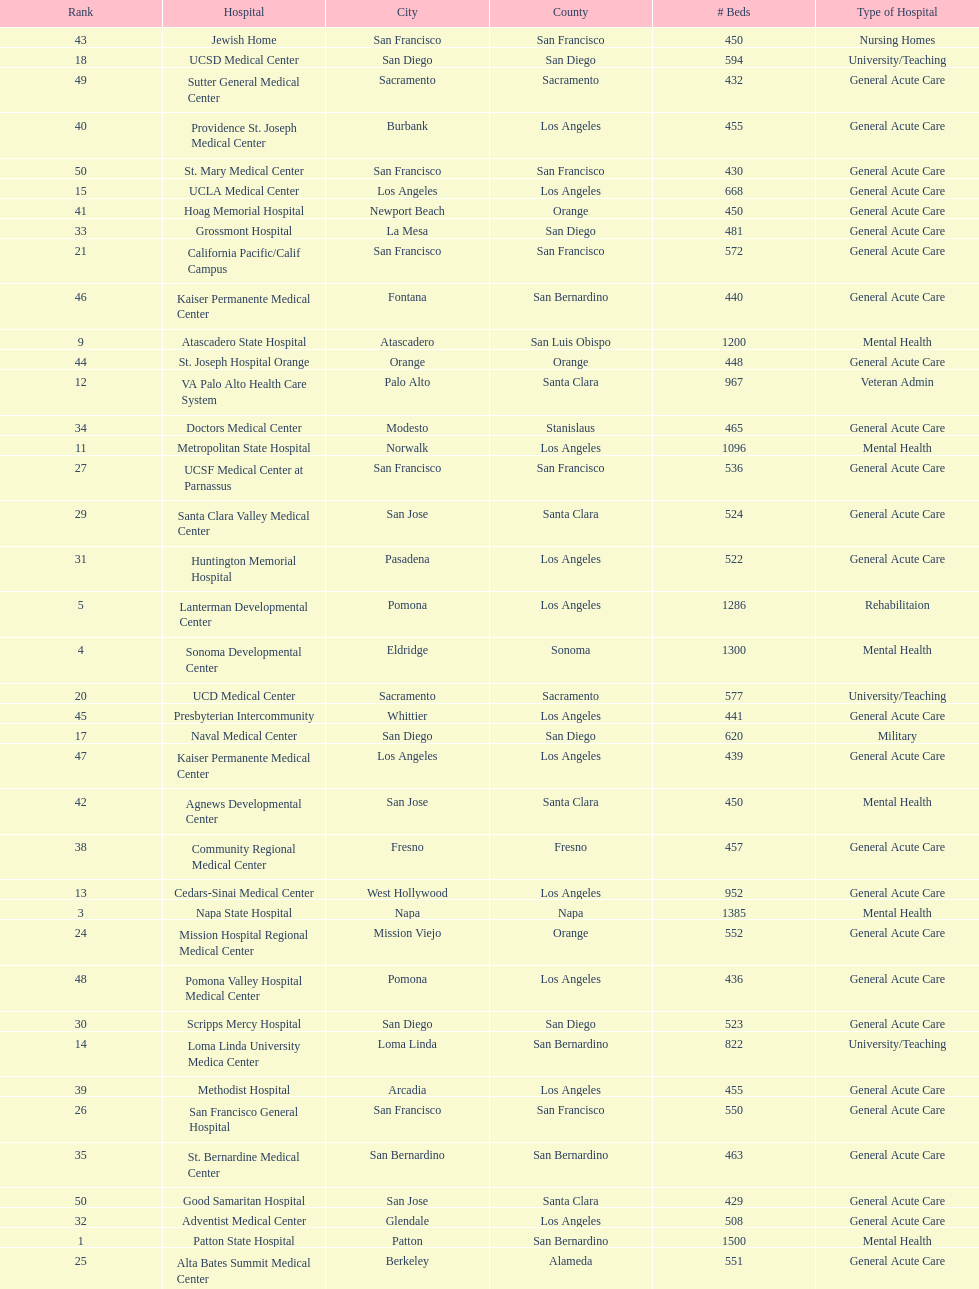Could you parse the entire table as a dict? {'header': ['Rank', 'Hospital', 'City', 'County', '# Beds', 'Type of Hospital'], 'rows': [['43', 'Jewish Home', 'San Francisco', 'San Francisco', '450', 'Nursing Homes'], ['18', 'UCSD Medical Center', 'San Diego', 'San Diego', '594', 'University/Teaching'], ['49', 'Sutter General Medical Center', 'Sacramento', 'Sacramento', '432', 'General Acute Care'], ['40', 'Providence St. Joseph Medical Center', 'Burbank', 'Los Angeles', '455', 'General Acute Care'], ['50', 'St. Mary Medical Center', 'San Francisco', 'San Francisco', '430', 'General Acute Care'], ['15', 'UCLA Medical Center', 'Los Angeles', 'Los Angeles', '668', 'General Acute Care'], ['41', 'Hoag Memorial Hospital', 'Newport Beach', 'Orange', '450', 'General Acute Care'], ['33', 'Grossmont Hospital', 'La Mesa', 'San Diego', '481', 'General Acute Care'], ['21', 'California Pacific/Calif Campus', 'San Francisco', 'San Francisco', '572', 'General Acute Care'], ['46', 'Kaiser Permanente Medical Center', 'Fontana', 'San Bernardino', '440', 'General Acute Care'], ['9', 'Atascadero State Hospital', 'Atascadero', 'San Luis Obispo', '1200', 'Mental Health'], ['44', 'St. Joseph Hospital Orange', 'Orange', 'Orange', '448', 'General Acute Care'], ['12', 'VA Palo Alto Health Care System', 'Palo Alto', 'Santa Clara', '967', 'Veteran Admin'], ['34', 'Doctors Medical Center', 'Modesto', 'Stanislaus', '465', 'General Acute Care'], ['11', 'Metropolitan State Hospital', 'Norwalk', 'Los Angeles', '1096', 'Mental Health'], ['27', 'UCSF Medical Center at Parnassus', 'San Francisco', 'San Francisco', '536', 'General Acute Care'], ['29', 'Santa Clara Valley Medical Center', 'San Jose', 'Santa Clara', '524', 'General Acute Care'], ['31', 'Huntington Memorial Hospital', 'Pasadena', 'Los Angeles', '522', 'General Acute Care'], ['5', 'Lanterman Developmental Center', 'Pomona', 'Los Angeles', '1286', 'Rehabilitaion'], ['4', 'Sonoma Developmental Center', 'Eldridge', 'Sonoma', '1300', 'Mental Health'], ['20', 'UCD Medical Center', 'Sacramento', 'Sacramento', '577', 'University/Teaching'], ['45', 'Presbyterian Intercommunity', 'Whittier', 'Los Angeles', '441', 'General Acute Care'], ['17', 'Naval Medical Center', 'San Diego', 'San Diego', '620', 'Military'], ['47', 'Kaiser Permanente Medical Center', 'Los Angeles', 'Los Angeles', '439', 'General Acute Care'], ['42', 'Agnews Developmental Center', 'San Jose', 'Santa Clara', '450', 'Mental Health'], ['38', 'Community Regional Medical Center', 'Fresno', 'Fresno', '457', 'General Acute Care'], ['13', 'Cedars-Sinai Medical Center', 'West Hollywood', 'Los Angeles', '952', 'General Acute Care'], ['3', 'Napa State Hospital', 'Napa', 'Napa', '1385', 'Mental Health'], ['24', 'Mission Hospital Regional Medical Center', 'Mission Viejo', 'Orange', '552', 'General Acute Care'], ['48', 'Pomona Valley Hospital Medical Center', 'Pomona', 'Los Angeles', '436', 'General Acute Care'], ['30', 'Scripps Mercy Hospital', 'San Diego', 'San Diego', '523', 'General Acute Care'], ['14', 'Loma Linda University Medica Center', 'Loma Linda', 'San Bernardino', '822', 'University/Teaching'], ['39', 'Methodist Hospital', 'Arcadia', 'Los Angeles', '455', 'General Acute Care'], ['26', 'San Francisco General Hospital', 'San Francisco', 'San Francisco', '550', 'General Acute Care'], ['35', 'St. Bernardine Medical Center', 'San Bernardino', 'San Bernardino', '463', 'General Acute Care'], ['50', 'Good Samaritan Hospital', 'San Jose', 'Santa Clara', '429', 'General Acute Care'], ['32', 'Adventist Medical Center', 'Glendale', 'Los Angeles', '508', 'General Acute Care'], ['1', 'Patton State Hospital', 'Patton', 'San Bernardino', '1500', 'Mental Health'], ['25', 'Alta Bates Summit Medical Center', 'Berkeley', 'Alameda', '551', 'General Acute Care'], ['23', 'Harbor UCLA Medical Center', 'Torrance', 'Los Angeles', '553', 'General Acute Care'], ['10', 'Veterans Home of California', 'Yountville', 'Napa', '1100', 'Veteran Admin'], ['36', 'UCI Medical Center', 'Orange', 'Orange', '462', 'General Acute Care'], ['16', 'Kaweah Delta Regional Medical Center', 'Visalia', 'Tulare', '629', 'General Acute Care'], ['19', 'UCSF Medical Center Mount Zion', 'San Francisco', 'San Francisco', '579', 'General Acute Care'], ['28', 'Alta Bates Summit Medical Center', 'Oakland', 'Alameda', '534', 'General Acute Care'], ['6', 'Fairview Developmental Center', 'Costa Mesa', 'Orange', '1218', 'Mental Health'], ['22', 'Long Beach Memorial Medical Center', 'Long Beach', 'Los Angeles', '568', 'General Acute Care'], ['8', 'Laguna Honda Hospital Rehabilitation Center', 'San Francisco', 'San Francisco', '1200', 'Nursing Homes'], ['2', 'LA County & USC Medical Center', 'Los Angeles', 'Los Angeles', '1395', 'General Acute Care'], ['37', 'Stanford Medical Center', 'Stanford', 'Santa Clara', '460', 'General Acute Care'], ['7', 'Porterville Developmental Center', 'Porterville', 'Tulare', '1210', 'Mental Health']]} What hospital in los angeles county providing hospital beds specifically for rehabilitation is ranked at least among the top 10 hospitals? Lanterman Developmental Center. 